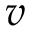<formula> <loc_0><loc_0><loc_500><loc_500>v</formula> 